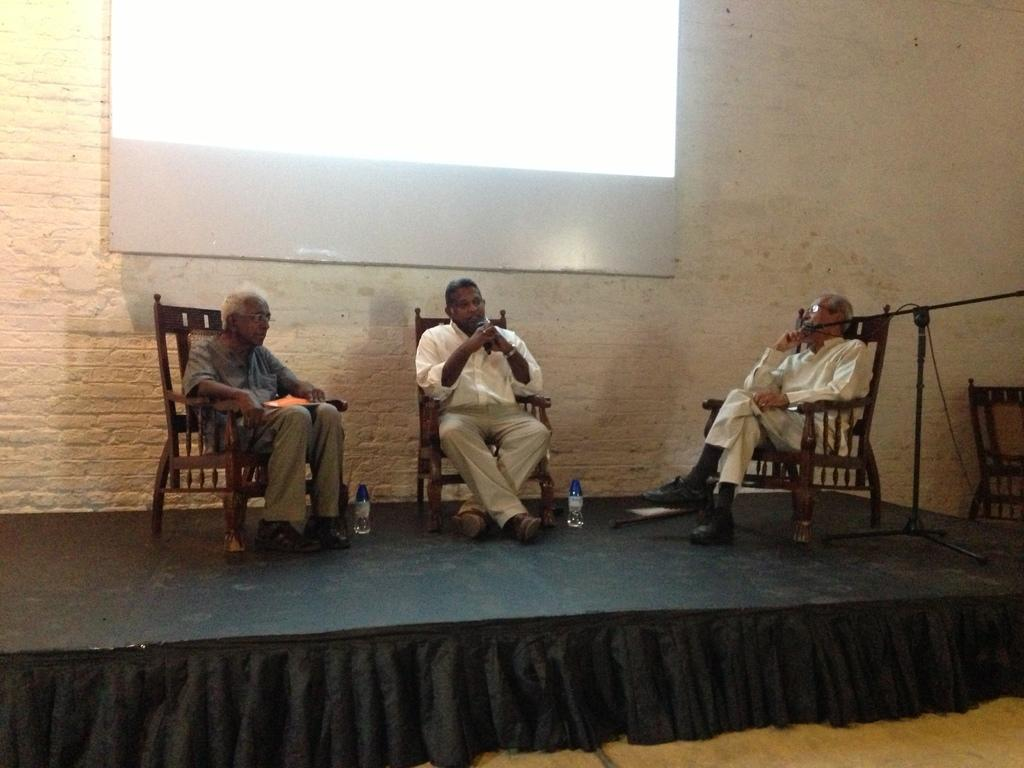How many people are in the image? There are three persons in the image. What are the persons doing in the image? The persons are sitting on chairs. What objects can be seen besides the chairs in the image? There are bottles visible in the image. What can be seen on the floor in the image? The floor is visible in the image. What is present in the background of the image? There is a wall and a screen in the background of the image. What type of stem can be seen growing from the wall in the image? There is no stem growing from the wall in the image. How many birds are flying in the image? There are no birds present in the image. 